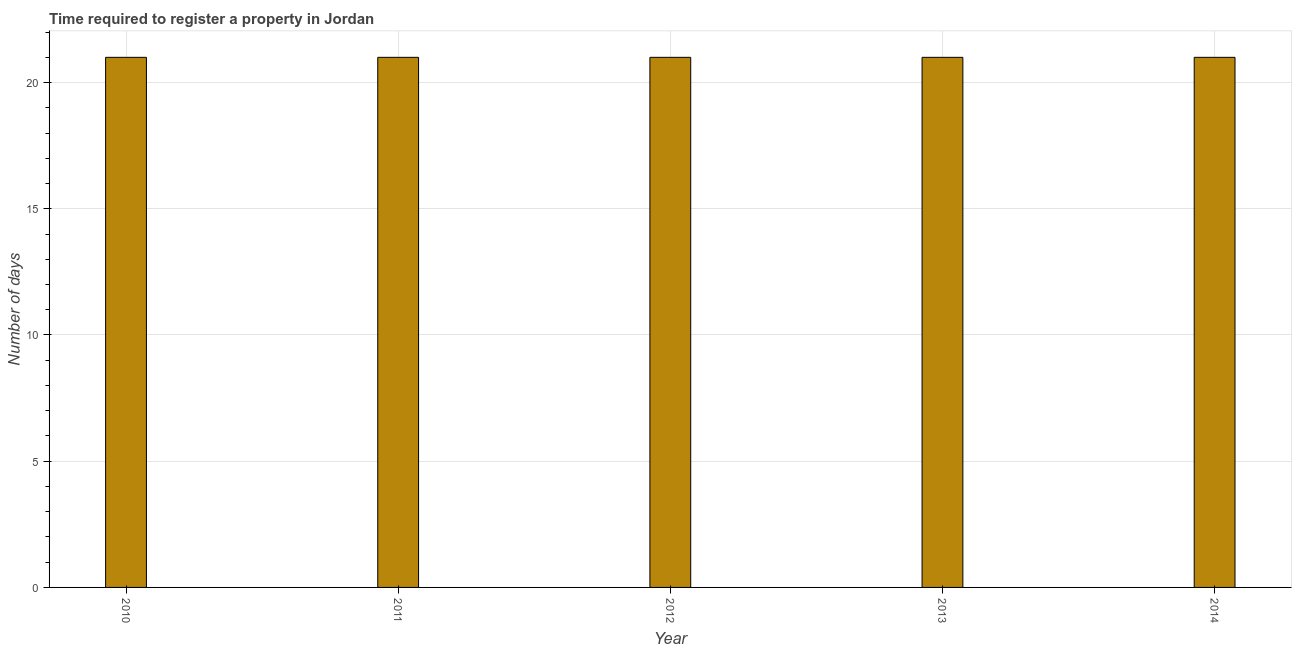Does the graph contain grids?
Give a very brief answer. Yes. What is the title of the graph?
Your response must be concise. Time required to register a property in Jordan. What is the label or title of the X-axis?
Your response must be concise. Year. What is the label or title of the Y-axis?
Your answer should be compact. Number of days. Across all years, what is the minimum number of days required to register property?
Offer a terse response. 21. In which year was the number of days required to register property maximum?
Offer a very short reply. 2010. What is the sum of the number of days required to register property?
Make the answer very short. 105. What is the difference between the number of days required to register property in 2011 and 2013?
Provide a short and direct response. 0. What is the average number of days required to register property per year?
Provide a succinct answer. 21. In how many years, is the number of days required to register property greater than 19 days?
Offer a very short reply. 5. Do a majority of the years between 2011 and 2010 (inclusive) have number of days required to register property greater than 20 days?
Provide a succinct answer. No. What is the ratio of the number of days required to register property in 2010 to that in 2012?
Ensure brevity in your answer.  1. Is the number of days required to register property in 2010 less than that in 2012?
Keep it short and to the point. No. What is the difference between the highest and the lowest number of days required to register property?
Offer a terse response. 0. In how many years, is the number of days required to register property greater than the average number of days required to register property taken over all years?
Your response must be concise. 0. Are all the bars in the graph horizontal?
Ensure brevity in your answer.  No. How many years are there in the graph?
Make the answer very short. 5. What is the Number of days in 2013?
Your answer should be compact. 21. What is the difference between the Number of days in 2010 and 2011?
Provide a succinct answer. 0. What is the difference between the Number of days in 2010 and 2013?
Provide a short and direct response. 0. What is the difference between the Number of days in 2010 and 2014?
Make the answer very short. 0. What is the difference between the Number of days in 2011 and 2013?
Keep it short and to the point. 0. What is the difference between the Number of days in 2011 and 2014?
Offer a very short reply. 0. What is the difference between the Number of days in 2012 and 2013?
Ensure brevity in your answer.  0. What is the difference between the Number of days in 2012 and 2014?
Provide a short and direct response. 0. What is the ratio of the Number of days in 2010 to that in 2011?
Offer a terse response. 1. What is the ratio of the Number of days in 2010 to that in 2013?
Your answer should be very brief. 1. What is the ratio of the Number of days in 2012 to that in 2013?
Provide a short and direct response. 1. 